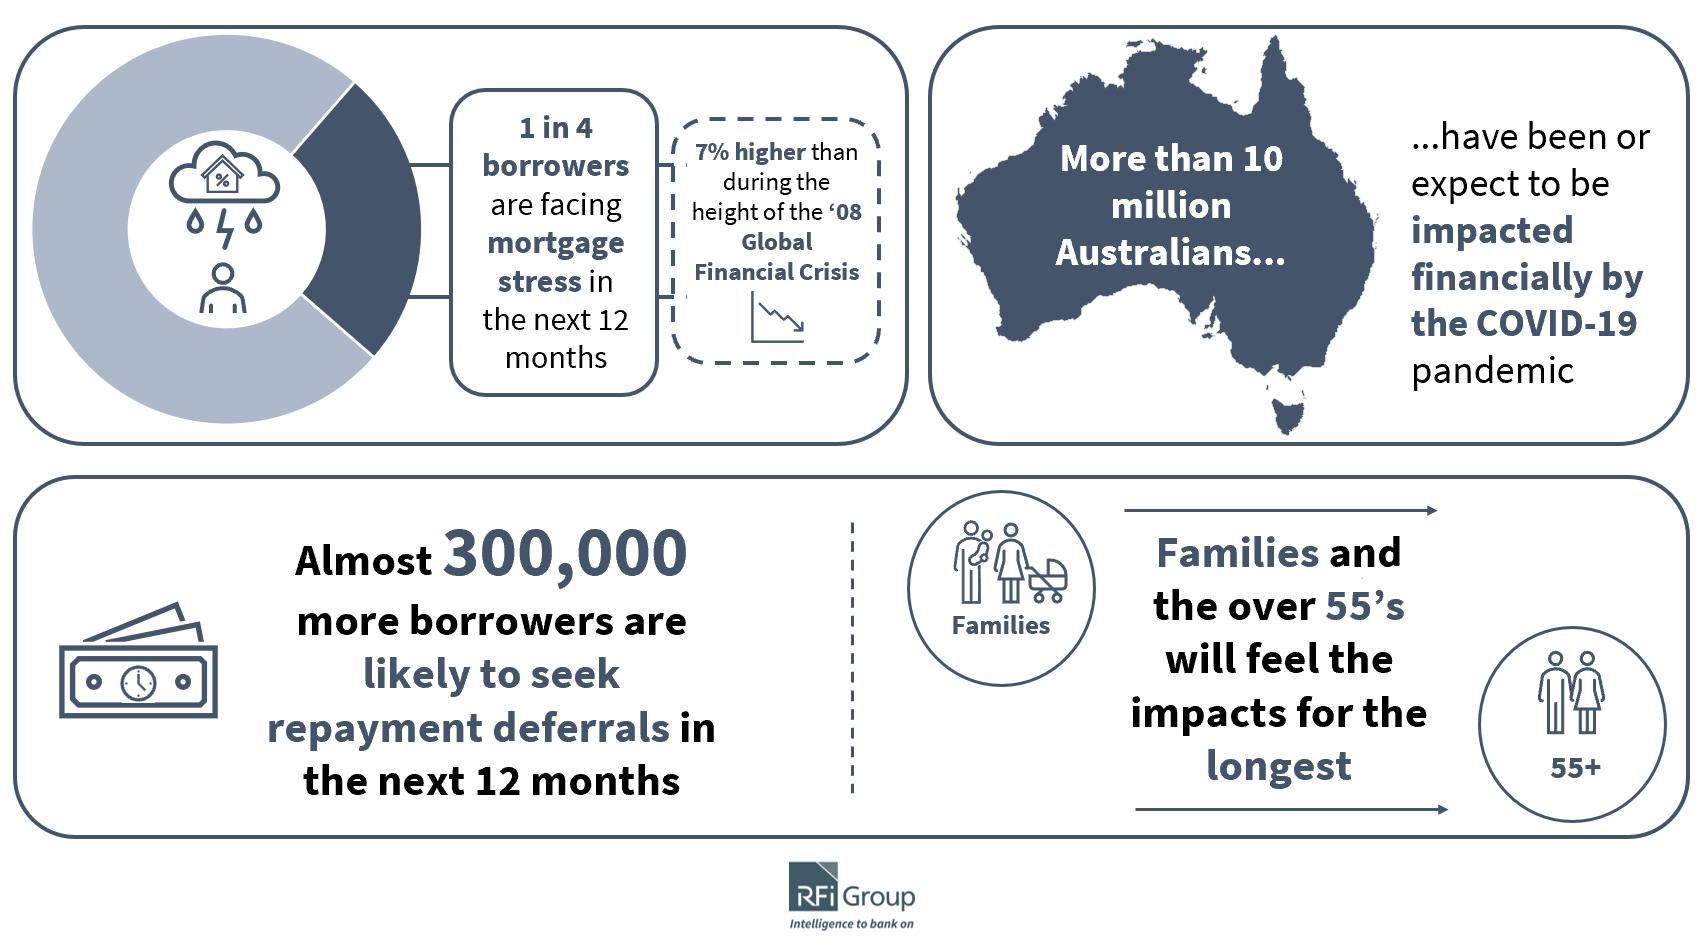Identify some key points in this picture. It is projected that approximately 10 million Australians will be financially impacted by the ongoing pandemic. The most vulnerable groups affected by COVID-19 are families and individuals over the age of 55. In the near future, it is expected that nearly 300,000 more borrowers will be asking for repayment deferrals. 